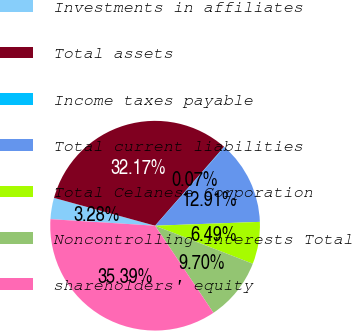<chart> <loc_0><loc_0><loc_500><loc_500><pie_chart><fcel>Investments in affiliates<fcel>Total assets<fcel>Income taxes payable<fcel>Total current liabilities<fcel>Total Celanese Corporation<fcel>Noncontrolling interests Total<fcel>shareholders' equity<nl><fcel>3.28%<fcel>32.17%<fcel>0.07%<fcel>12.91%<fcel>6.49%<fcel>9.7%<fcel>35.39%<nl></chart> 